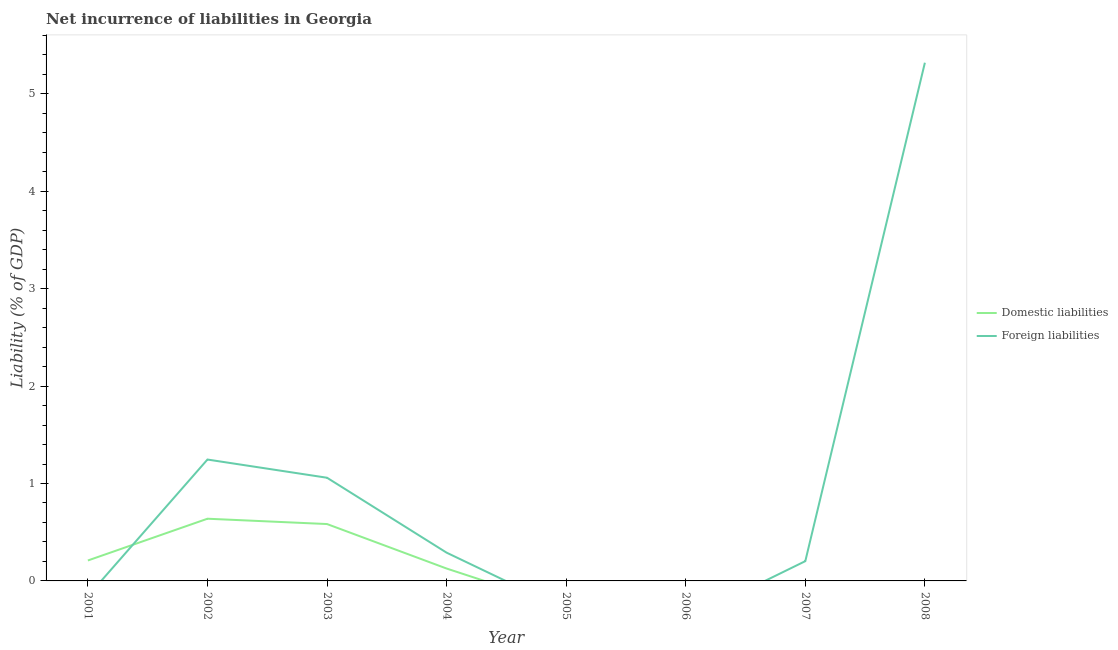Does the line corresponding to incurrence of domestic liabilities intersect with the line corresponding to incurrence of foreign liabilities?
Make the answer very short. Yes. What is the incurrence of domestic liabilities in 2007?
Provide a succinct answer. 0. Across all years, what is the maximum incurrence of foreign liabilities?
Provide a short and direct response. 5.32. Across all years, what is the minimum incurrence of foreign liabilities?
Offer a terse response. 0. What is the total incurrence of foreign liabilities in the graph?
Give a very brief answer. 8.12. What is the difference between the incurrence of domestic liabilities in 2002 and that in 2004?
Your response must be concise. 0.51. What is the difference between the incurrence of foreign liabilities in 2004 and the incurrence of domestic liabilities in 2003?
Your answer should be compact. -0.29. What is the average incurrence of foreign liabilities per year?
Your answer should be compact. 1.01. In the year 2002, what is the difference between the incurrence of domestic liabilities and incurrence of foreign liabilities?
Provide a succinct answer. -0.61. What is the ratio of the incurrence of foreign liabilities in 2002 to that in 2003?
Your answer should be compact. 1.18. Is the incurrence of foreign liabilities in 2003 less than that in 2008?
Offer a terse response. Yes. What is the difference between the highest and the second highest incurrence of foreign liabilities?
Your answer should be very brief. 4.07. What is the difference between the highest and the lowest incurrence of foreign liabilities?
Ensure brevity in your answer.  5.32. How many lines are there?
Keep it short and to the point. 2. What is the difference between two consecutive major ticks on the Y-axis?
Offer a very short reply. 1. Are the values on the major ticks of Y-axis written in scientific E-notation?
Your response must be concise. No. Does the graph contain grids?
Your answer should be compact. No. Where does the legend appear in the graph?
Make the answer very short. Center right. What is the title of the graph?
Give a very brief answer. Net incurrence of liabilities in Georgia. Does "IMF nonconcessional" appear as one of the legend labels in the graph?
Your answer should be compact. No. What is the label or title of the X-axis?
Keep it short and to the point. Year. What is the label or title of the Y-axis?
Your answer should be very brief. Liability (% of GDP). What is the Liability (% of GDP) in Domestic liabilities in 2001?
Provide a succinct answer. 0.21. What is the Liability (% of GDP) in Domestic liabilities in 2002?
Give a very brief answer. 0.64. What is the Liability (% of GDP) in Foreign liabilities in 2002?
Offer a terse response. 1.25. What is the Liability (% of GDP) in Domestic liabilities in 2003?
Ensure brevity in your answer.  0.58. What is the Liability (% of GDP) of Foreign liabilities in 2003?
Give a very brief answer. 1.06. What is the Liability (% of GDP) in Domestic liabilities in 2004?
Offer a terse response. 0.13. What is the Liability (% of GDP) of Foreign liabilities in 2004?
Give a very brief answer. 0.29. What is the Liability (% of GDP) of Domestic liabilities in 2005?
Give a very brief answer. 0. What is the Liability (% of GDP) in Foreign liabilities in 2005?
Your answer should be compact. 0. What is the Liability (% of GDP) in Foreign liabilities in 2007?
Offer a very short reply. 0.2. What is the Liability (% of GDP) of Domestic liabilities in 2008?
Offer a terse response. 0. What is the Liability (% of GDP) in Foreign liabilities in 2008?
Provide a short and direct response. 5.32. Across all years, what is the maximum Liability (% of GDP) in Domestic liabilities?
Provide a short and direct response. 0.64. Across all years, what is the maximum Liability (% of GDP) of Foreign liabilities?
Give a very brief answer. 5.32. What is the total Liability (% of GDP) in Domestic liabilities in the graph?
Provide a succinct answer. 1.56. What is the total Liability (% of GDP) of Foreign liabilities in the graph?
Provide a succinct answer. 8.12. What is the difference between the Liability (% of GDP) of Domestic liabilities in 2001 and that in 2002?
Offer a terse response. -0.43. What is the difference between the Liability (% of GDP) of Domestic liabilities in 2001 and that in 2003?
Offer a terse response. -0.37. What is the difference between the Liability (% of GDP) in Domestic liabilities in 2001 and that in 2004?
Make the answer very short. 0.08. What is the difference between the Liability (% of GDP) in Domestic liabilities in 2002 and that in 2003?
Give a very brief answer. 0.05. What is the difference between the Liability (% of GDP) of Foreign liabilities in 2002 and that in 2003?
Offer a very short reply. 0.19. What is the difference between the Liability (% of GDP) of Domestic liabilities in 2002 and that in 2004?
Offer a terse response. 0.51. What is the difference between the Liability (% of GDP) in Foreign liabilities in 2002 and that in 2004?
Offer a terse response. 0.96. What is the difference between the Liability (% of GDP) in Foreign liabilities in 2002 and that in 2007?
Keep it short and to the point. 1.04. What is the difference between the Liability (% of GDP) of Foreign liabilities in 2002 and that in 2008?
Your answer should be very brief. -4.07. What is the difference between the Liability (% of GDP) of Domestic liabilities in 2003 and that in 2004?
Your answer should be compact. 0.46. What is the difference between the Liability (% of GDP) of Foreign liabilities in 2003 and that in 2004?
Your answer should be very brief. 0.77. What is the difference between the Liability (% of GDP) in Foreign liabilities in 2003 and that in 2007?
Offer a very short reply. 0.86. What is the difference between the Liability (% of GDP) in Foreign liabilities in 2003 and that in 2008?
Give a very brief answer. -4.26. What is the difference between the Liability (% of GDP) in Foreign liabilities in 2004 and that in 2007?
Give a very brief answer. 0.09. What is the difference between the Liability (% of GDP) of Foreign liabilities in 2004 and that in 2008?
Offer a terse response. -5.03. What is the difference between the Liability (% of GDP) in Foreign liabilities in 2007 and that in 2008?
Provide a succinct answer. -5.12. What is the difference between the Liability (% of GDP) of Domestic liabilities in 2001 and the Liability (% of GDP) of Foreign liabilities in 2002?
Keep it short and to the point. -1.04. What is the difference between the Liability (% of GDP) of Domestic liabilities in 2001 and the Liability (% of GDP) of Foreign liabilities in 2003?
Give a very brief answer. -0.85. What is the difference between the Liability (% of GDP) of Domestic liabilities in 2001 and the Liability (% of GDP) of Foreign liabilities in 2004?
Your response must be concise. -0.08. What is the difference between the Liability (% of GDP) in Domestic liabilities in 2001 and the Liability (% of GDP) in Foreign liabilities in 2007?
Offer a very short reply. 0.01. What is the difference between the Liability (% of GDP) in Domestic liabilities in 2001 and the Liability (% of GDP) in Foreign liabilities in 2008?
Keep it short and to the point. -5.11. What is the difference between the Liability (% of GDP) of Domestic liabilities in 2002 and the Liability (% of GDP) of Foreign liabilities in 2003?
Offer a very short reply. -0.42. What is the difference between the Liability (% of GDP) of Domestic liabilities in 2002 and the Liability (% of GDP) of Foreign liabilities in 2004?
Your answer should be very brief. 0.35. What is the difference between the Liability (% of GDP) of Domestic liabilities in 2002 and the Liability (% of GDP) of Foreign liabilities in 2007?
Provide a short and direct response. 0.44. What is the difference between the Liability (% of GDP) of Domestic liabilities in 2002 and the Liability (% of GDP) of Foreign liabilities in 2008?
Make the answer very short. -4.68. What is the difference between the Liability (% of GDP) of Domestic liabilities in 2003 and the Liability (% of GDP) of Foreign liabilities in 2004?
Your answer should be very brief. 0.29. What is the difference between the Liability (% of GDP) of Domestic liabilities in 2003 and the Liability (% of GDP) of Foreign liabilities in 2007?
Provide a succinct answer. 0.38. What is the difference between the Liability (% of GDP) of Domestic liabilities in 2003 and the Liability (% of GDP) of Foreign liabilities in 2008?
Provide a short and direct response. -4.74. What is the difference between the Liability (% of GDP) of Domestic liabilities in 2004 and the Liability (% of GDP) of Foreign liabilities in 2007?
Your answer should be compact. -0.08. What is the difference between the Liability (% of GDP) in Domestic liabilities in 2004 and the Liability (% of GDP) in Foreign liabilities in 2008?
Offer a terse response. -5.19. What is the average Liability (% of GDP) in Domestic liabilities per year?
Provide a succinct answer. 0.19. What is the average Liability (% of GDP) of Foreign liabilities per year?
Make the answer very short. 1.01. In the year 2002, what is the difference between the Liability (% of GDP) in Domestic liabilities and Liability (% of GDP) in Foreign liabilities?
Provide a succinct answer. -0.61. In the year 2003, what is the difference between the Liability (% of GDP) of Domestic liabilities and Liability (% of GDP) of Foreign liabilities?
Make the answer very short. -0.48. In the year 2004, what is the difference between the Liability (% of GDP) of Domestic liabilities and Liability (% of GDP) of Foreign liabilities?
Your answer should be compact. -0.16. What is the ratio of the Liability (% of GDP) of Domestic liabilities in 2001 to that in 2002?
Offer a terse response. 0.33. What is the ratio of the Liability (% of GDP) in Domestic liabilities in 2001 to that in 2003?
Ensure brevity in your answer.  0.36. What is the ratio of the Liability (% of GDP) of Domestic liabilities in 2001 to that in 2004?
Your answer should be very brief. 1.65. What is the ratio of the Liability (% of GDP) in Domestic liabilities in 2002 to that in 2003?
Offer a very short reply. 1.09. What is the ratio of the Liability (% of GDP) of Foreign liabilities in 2002 to that in 2003?
Provide a succinct answer. 1.18. What is the ratio of the Liability (% of GDP) in Domestic liabilities in 2002 to that in 2004?
Your answer should be compact. 5.02. What is the ratio of the Liability (% of GDP) of Foreign liabilities in 2002 to that in 2004?
Give a very brief answer. 4.29. What is the ratio of the Liability (% of GDP) of Foreign liabilities in 2002 to that in 2007?
Your answer should be compact. 6.14. What is the ratio of the Liability (% of GDP) of Foreign liabilities in 2002 to that in 2008?
Your response must be concise. 0.23. What is the ratio of the Liability (% of GDP) in Domestic liabilities in 2003 to that in 2004?
Provide a short and direct response. 4.59. What is the ratio of the Liability (% of GDP) in Foreign liabilities in 2003 to that in 2004?
Give a very brief answer. 3.65. What is the ratio of the Liability (% of GDP) of Foreign liabilities in 2003 to that in 2007?
Provide a short and direct response. 5.22. What is the ratio of the Liability (% of GDP) in Foreign liabilities in 2003 to that in 2008?
Provide a short and direct response. 0.2. What is the ratio of the Liability (% of GDP) in Foreign liabilities in 2004 to that in 2007?
Your response must be concise. 1.43. What is the ratio of the Liability (% of GDP) of Foreign liabilities in 2004 to that in 2008?
Give a very brief answer. 0.05. What is the ratio of the Liability (% of GDP) in Foreign liabilities in 2007 to that in 2008?
Offer a terse response. 0.04. What is the difference between the highest and the second highest Liability (% of GDP) of Domestic liabilities?
Offer a terse response. 0.05. What is the difference between the highest and the second highest Liability (% of GDP) in Foreign liabilities?
Give a very brief answer. 4.07. What is the difference between the highest and the lowest Liability (% of GDP) in Domestic liabilities?
Keep it short and to the point. 0.64. What is the difference between the highest and the lowest Liability (% of GDP) of Foreign liabilities?
Give a very brief answer. 5.32. 